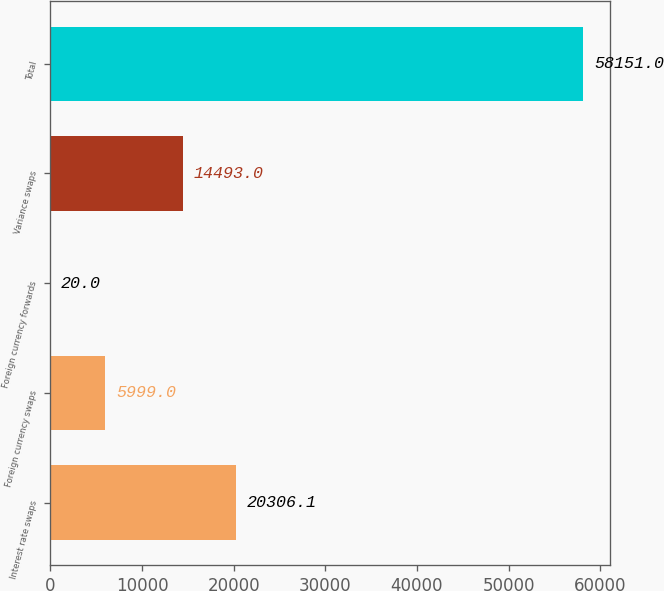Convert chart to OTSL. <chart><loc_0><loc_0><loc_500><loc_500><bar_chart><fcel>Interest rate swaps<fcel>Foreign currency swaps<fcel>Foreign currency forwards<fcel>Variance swaps<fcel>Total<nl><fcel>20306.1<fcel>5999<fcel>20<fcel>14493<fcel>58151<nl></chart> 